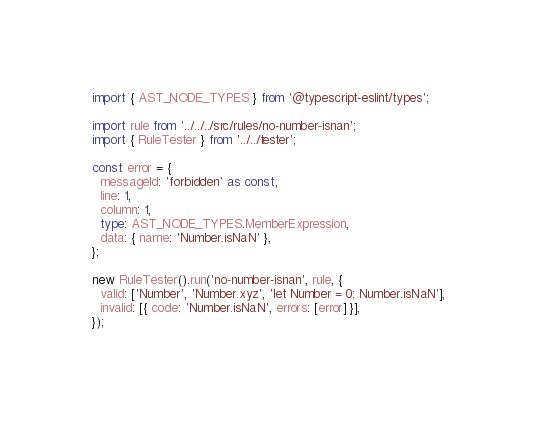<code> <loc_0><loc_0><loc_500><loc_500><_TypeScript_>import { AST_NODE_TYPES } from '@typescript-eslint/types';

import rule from '../../../src/rules/no-number-isnan';
import { RuleTester } from '../../tester';

const error = {
  messageId: 'forbidden' as const,
  line: 1,
  column: 1,
  type: AST_NODE_TYPES.MemberExpression,
  data: { name: 'Number.isNaN' },
};

new RuleTester().run('no-number-isnan', rule, {
  valid: ['Number', 'Number.xyz', 'let Number = 0; Number.isNaN'],
  invalid: [{ code: 'Number.isNaN', errors: [error] }],
});
</code> 